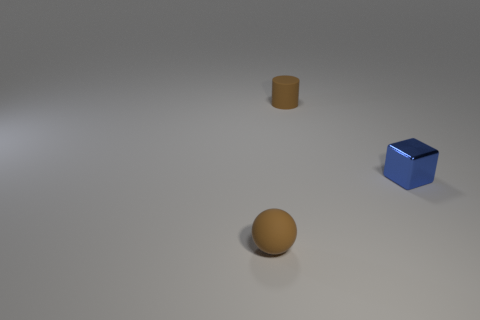What number of other objects are the same size as the block?
Your answer should be compact. 2. What number of things are either tiny metallic cubes or brown things left of the tiny brown cylinder?
Provide a short and direct response. 2. Are there an equal number of cubes on the left side of the tiny brown cylinder and brown matte balls?
Your answer should be very brief. No. The small object that is the same material as the brown cylinder is what shape?
Provide a short and direct response. Sphere. Is there another tiny cube that has the same color as the tiny cube?
Keep it short and to the point. No. How many metallic things are small cylinders or blue cubes?
Provide a succinct answer. 1. How many small objects are in front of the small brown object in front of the small blue shiny block?
Your response must be concise. 0. How many other purple cylinders have the same material as the cylinder?
Make the answer very short. 0. How many big things are blue matte blocks or shiny objects?
Your response must be concise. 0. The tiny thing that is left of the blue metallic cube and in front of the brown rubber cylinder has what shape?
Offer a terse response. Sphere. 